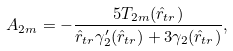Convert formula to latex. <formula><loc_0><loc_0><loc_500><loc_500>A _ { 2 m } = - \frac { 5 T _ { 2 m } ( \hat { r } _ { t r } ) } { \hat { r } _ { t r } \gamma _ { 2 } ^ { \prime } ( \hat { r } _ { t r } ) + 3 \gamma _ { 2 } ( \hat { r } _ { t r } ) } ,</formula> 